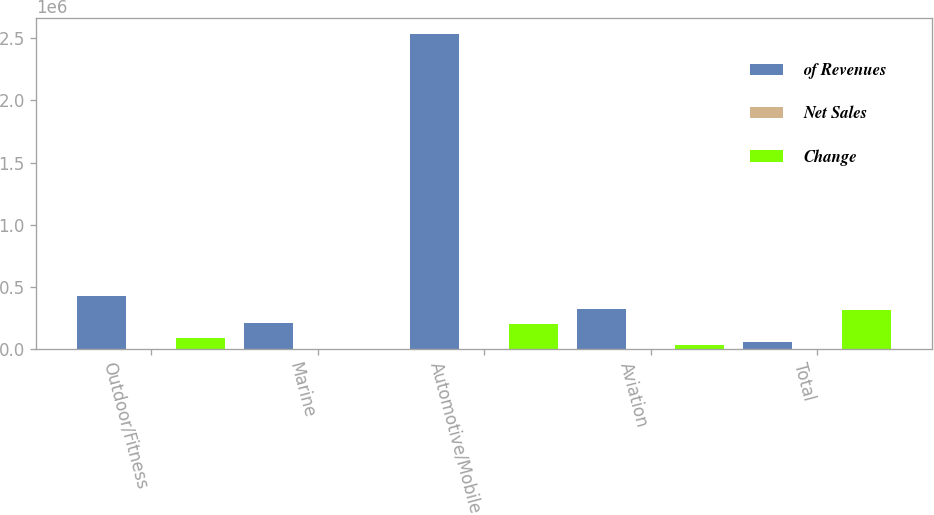Convert chart. <chart><loc_0><loc_0><loc_500><loc_500><stacked_bar_chart><ecel><fcel>Outdoor/Fitness<fcel>Marine<fcel>Automotive/Mobile<fcel>Aviation<fcel>Total<nl><fcel>of Revenues<fcel>427783<fcel>204477<fcel>2.53841e+06<fcel>323406<fcel>58226.5<nl><fcel>Net Sales<fcel>12.2<fcel>5.9<fcel>72.6<fcel>9.3<fcel>100<nl><fcel>Change<fcel>88042<fcel>1078<fcel>196227<fcel>28411<fcel>313758<nl></chart> 